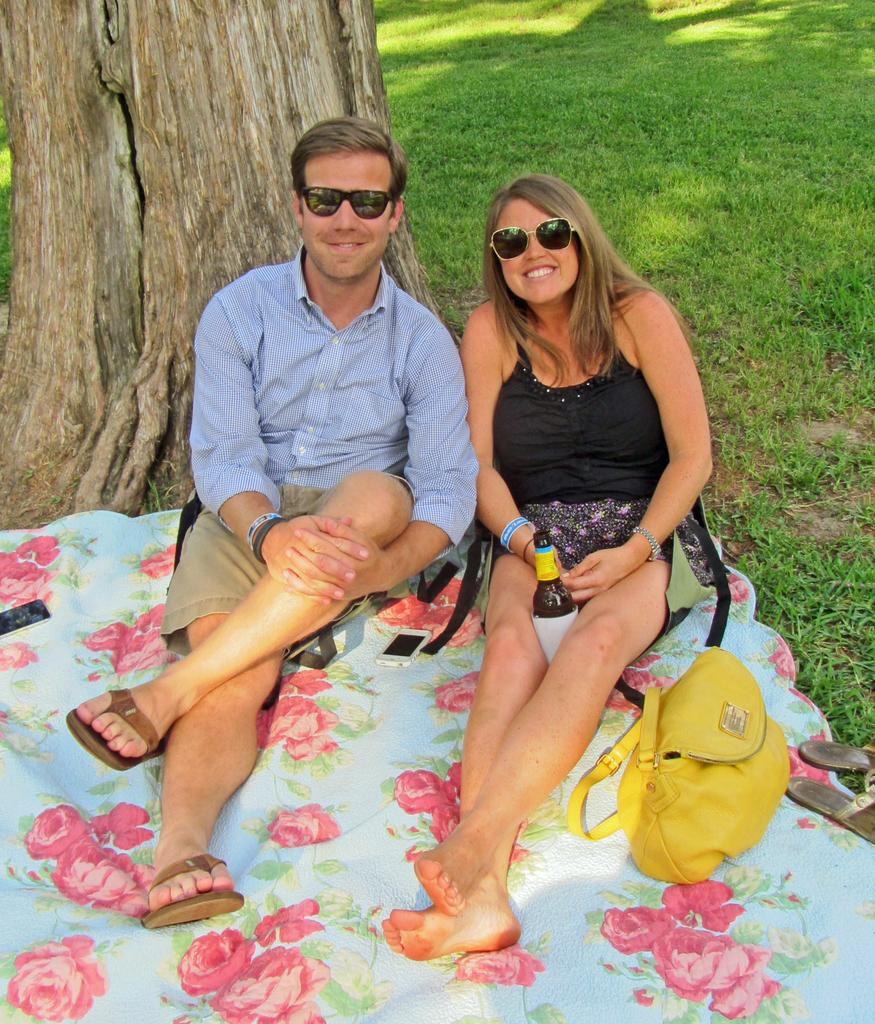How many people are present in the image? There are two people sitting in the image. Can you describe the setting where the people are located? The image features a tree on the left side, which suggests an outdoor or park setting. What type of beam is holding up the crow in the image? There is no beam or crow present in the image. What is the maid doing in the image? There is no maid present in the image. 